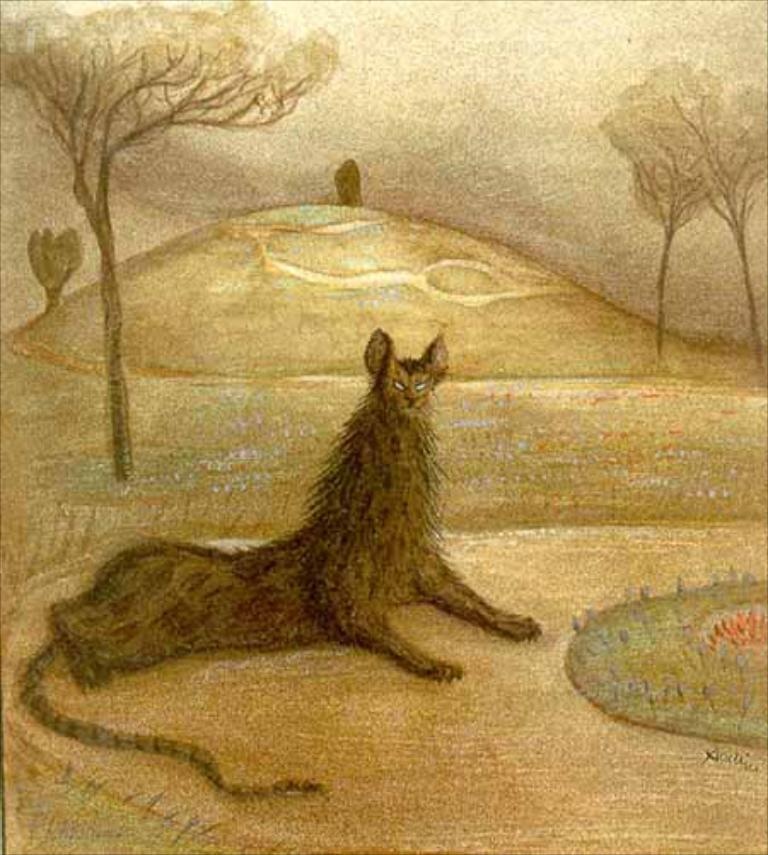What is the main subject of the picture? The main subject of the picture is a painted image. What can be seen around the painted image? Trees and plants are visible around the painted image. What type of insect can be seen crawling on the nerve in the image? There is no insect or nerve present in the image; it features a painted image surrounded by trees and plants. 